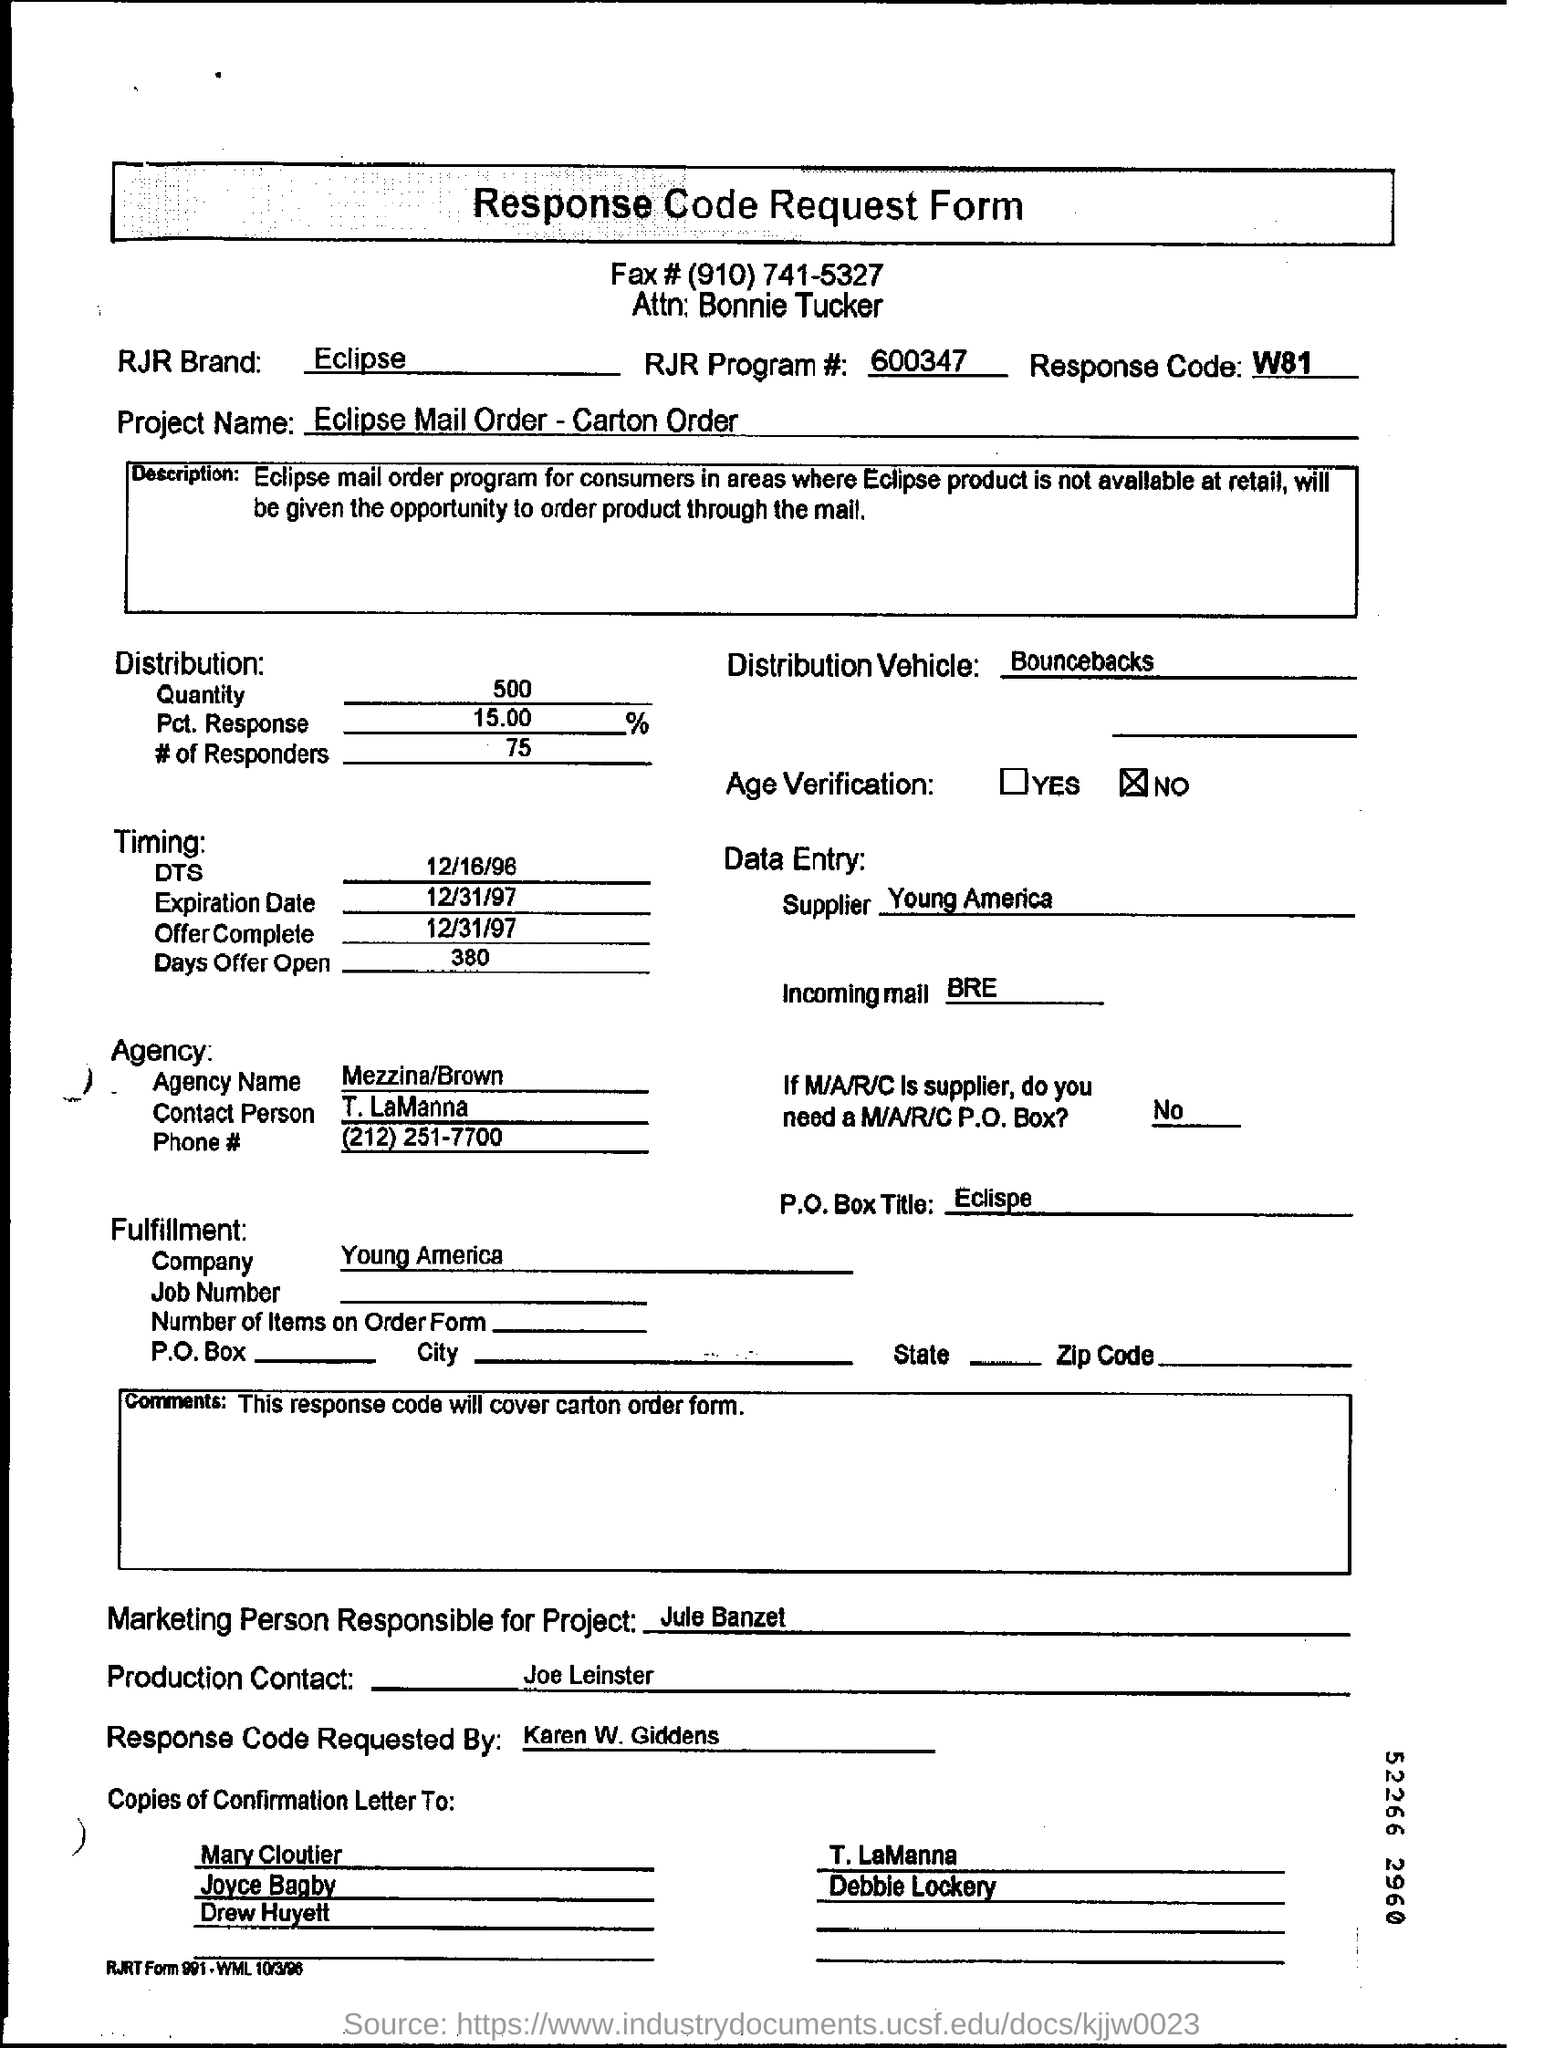Highlight a few significant elements in this photo. The expiration date mentioned in the request form is December 31, 1997. The distribution quantity specified in the request form is 500.. The project name mentioned in the request form is 'Eclipse Mail Order - Carton Order.' The response code mentioned in the document is W81. The document indicates that the agency contact person is T. LaManna. 